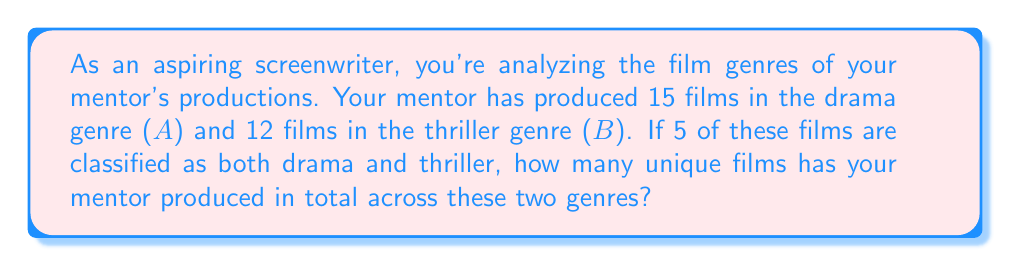Help me with this question. To solve this problem, we need to use the concept of set theory, specifically the formula for the number of elements in the union of two sets:

$$ |A \cup B| = |A| + |B| - |A \cap B| $$

Where:
- $|A \cup B|$ is the number of elements in the union of sets $A$ and $B$
- $|A|$ is the number of elements in set $A$
- $|B|$ is the number of elements in set $B$
- $|A \cap B|$ is the number of elements in the intersection of sets $A$ and $B$

Given:
- $|A|$ (number of drama films) = 15
- $|B|$ (number of thriller films) = 12
- $|A \cap B|$ (number of films that are both drama and thriller) = 5

Now, let's substitute these values into the formula:

$$ |A \cup B| = 15 + 12 - 5 $$

$$ |A \cup B| = 27 - 5 $$

$$ |A \cup B| = 22 $$

Therefore, the total number of unique films produced by your mentor across the drama and thriller genres is 22.
Answer: 22 films 